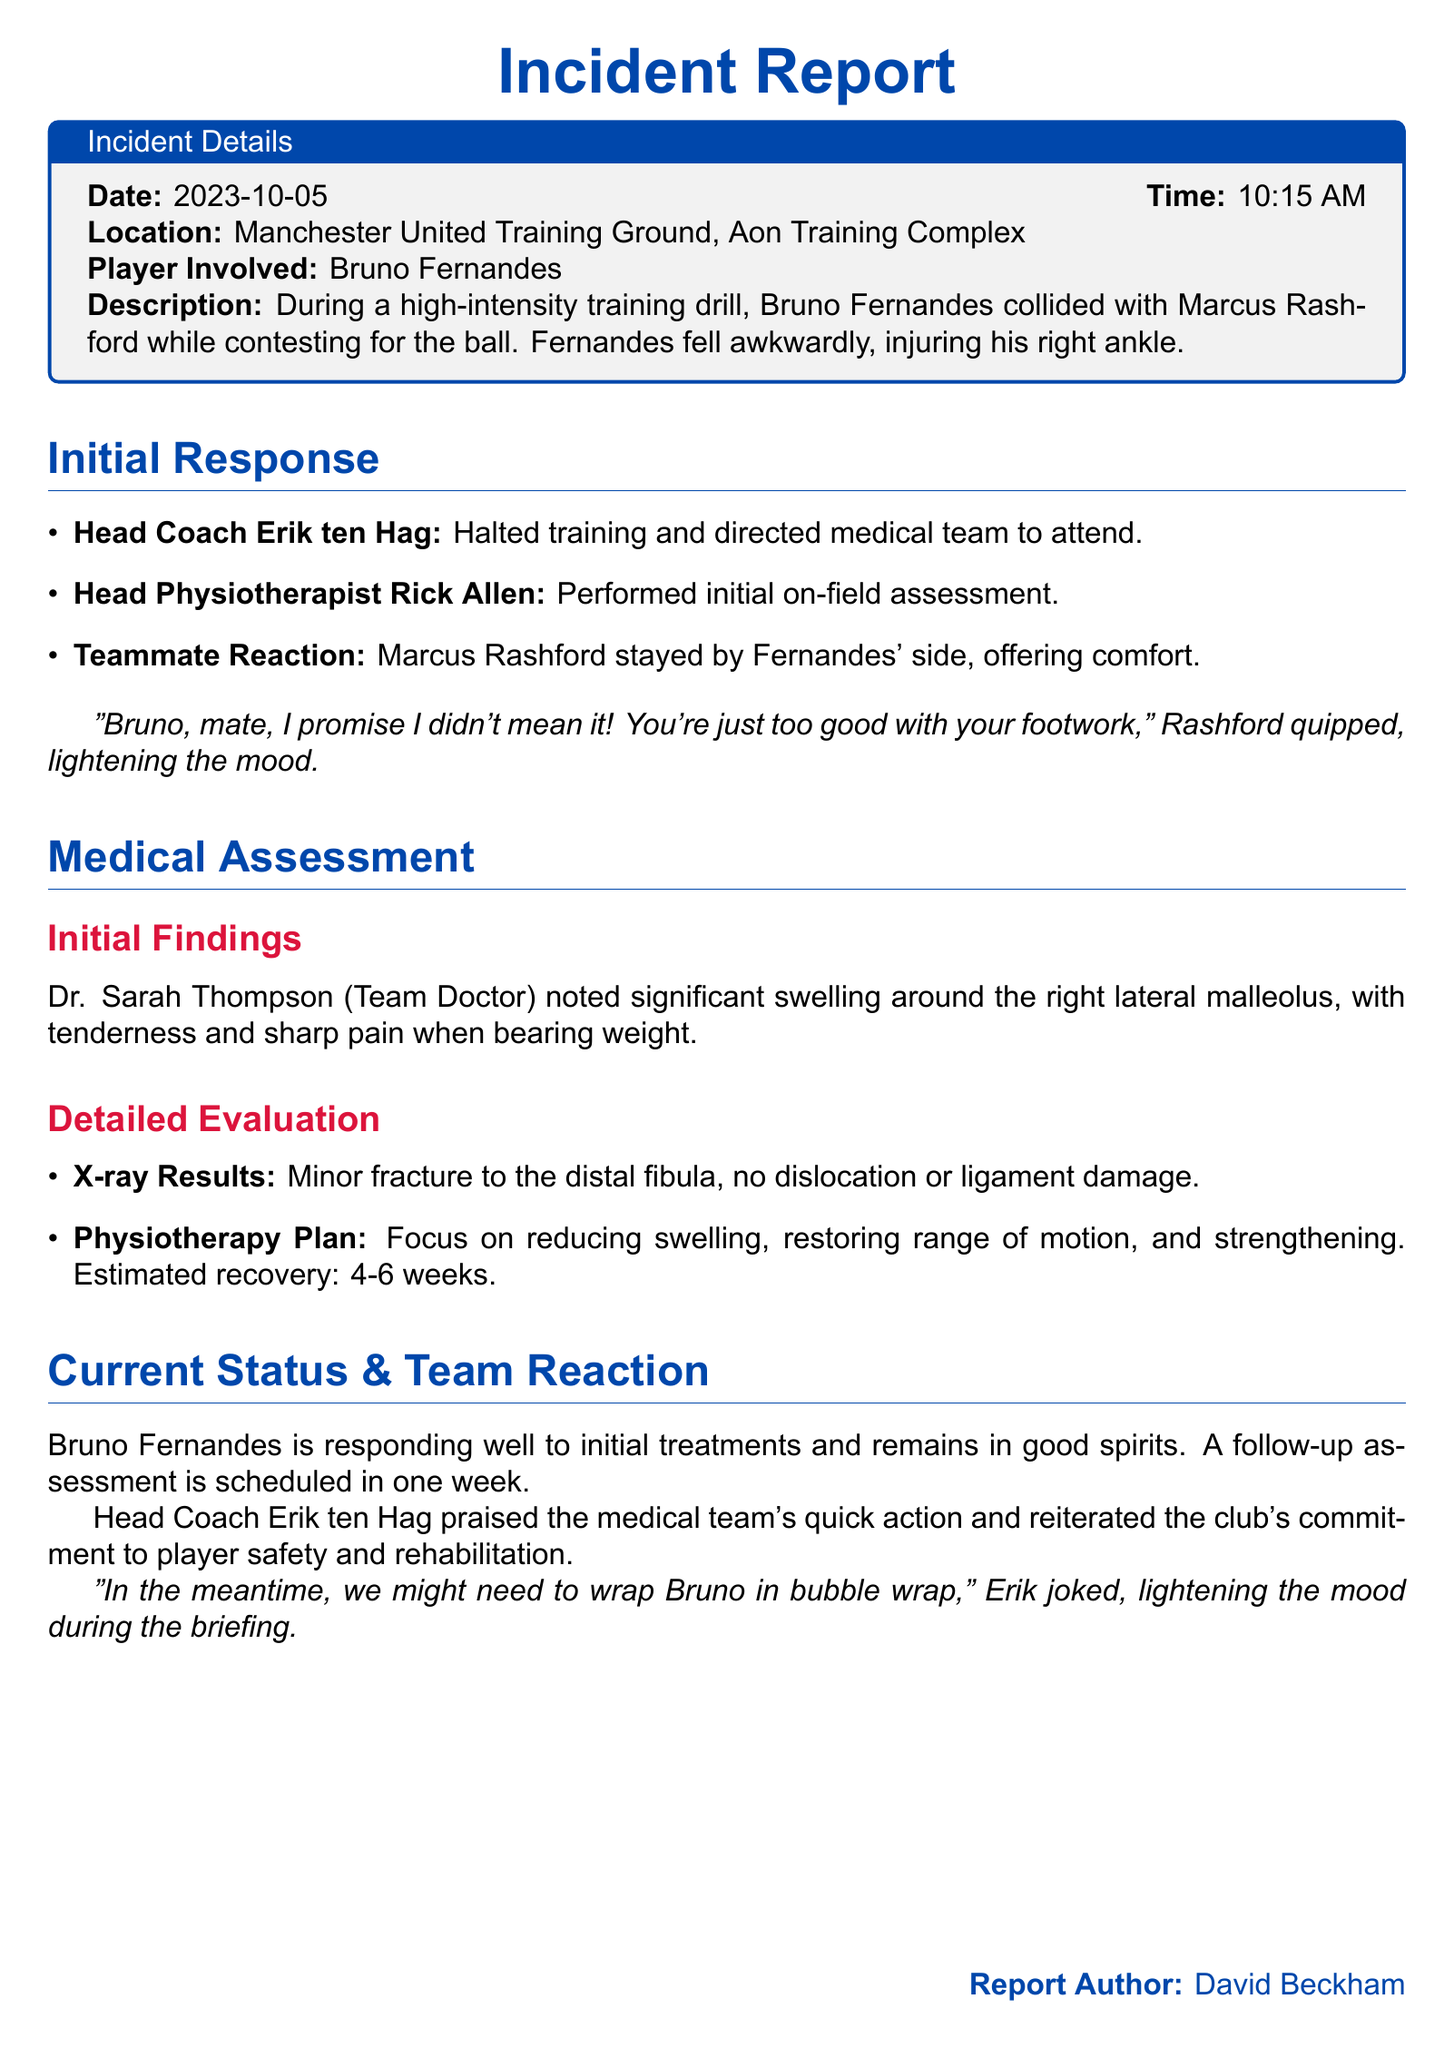What date did the incident occur? The date of the incident is mentioned at the beginning of the report.
Answer: 2023-10-05 Who was the player involved in the incident? The report specifically names the player who was injured during training.
Answer: Bruno Fernandes What was the time of the incident? The time of the incident is stated clearly in the report.
Answer: 10:15 AM What was the injury sustained by Bruno Fernandes? The description of the injury is provided in the medical assessment section.
Answer: Right ankle injury How long is the estimated recovery time for Fernandes? The report includes a specific estimate regarding the recovery duration.
Answer: 4-6 weeks What did Marcus Rashford say during the incident? The report includes a light-hearted quote from Rashford during his reaction.
Answer: "Bruno, mate, I promise I didn't mean it!" Who halted the training session? The report clearly states who took action to stop the training after the incident.
Answer: Erik ten Hag What type of fracture did Fernandes sustain? The detailed evaluation section specifies the nature of the injury.
Answer: Minor fracture Who performed the initial assessment? The report mentions who first assessed the injury on the field.
Answer: Rick Allen 